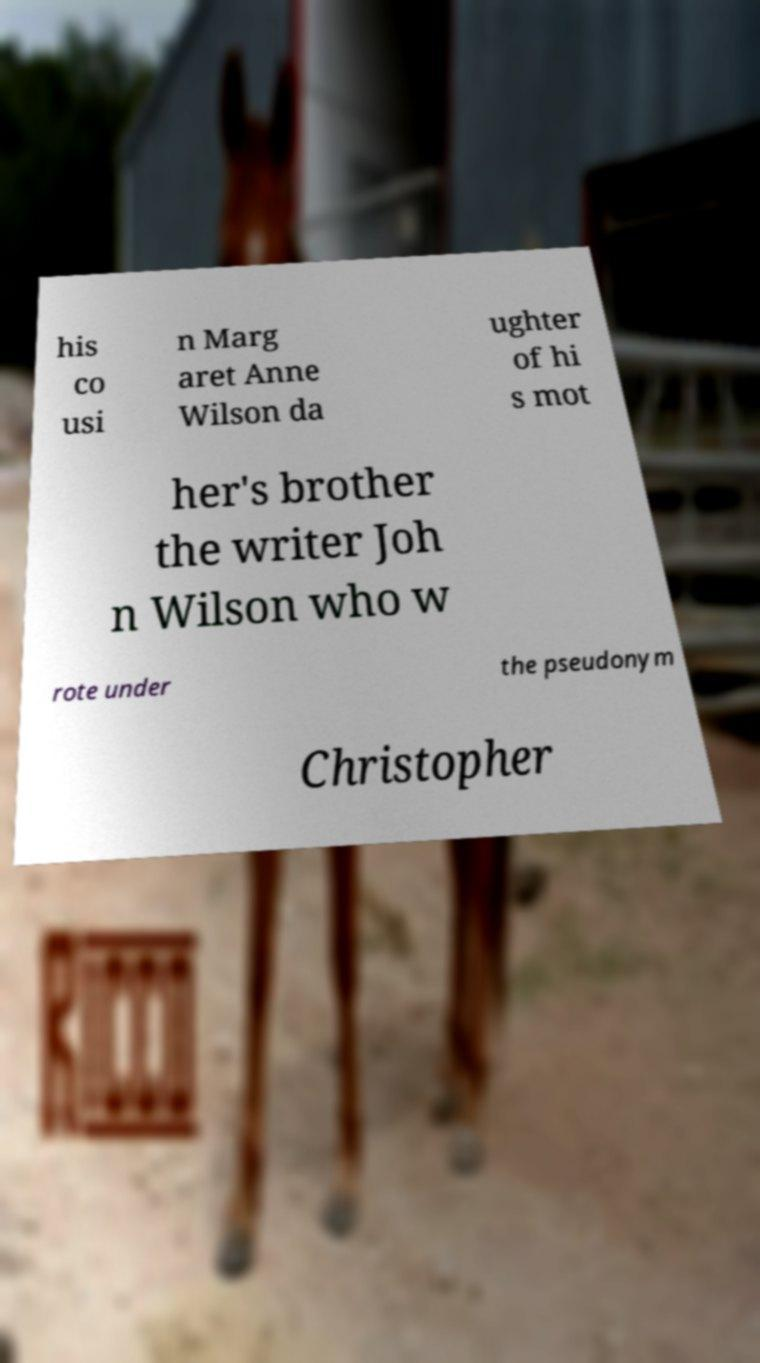Could you extract and type out the text from this image? his co usi n Marg aret Anne Wilson da ughter of hi s mot her's brother the writer Joh n Wilson who w rote under the pseudonym Christopher 